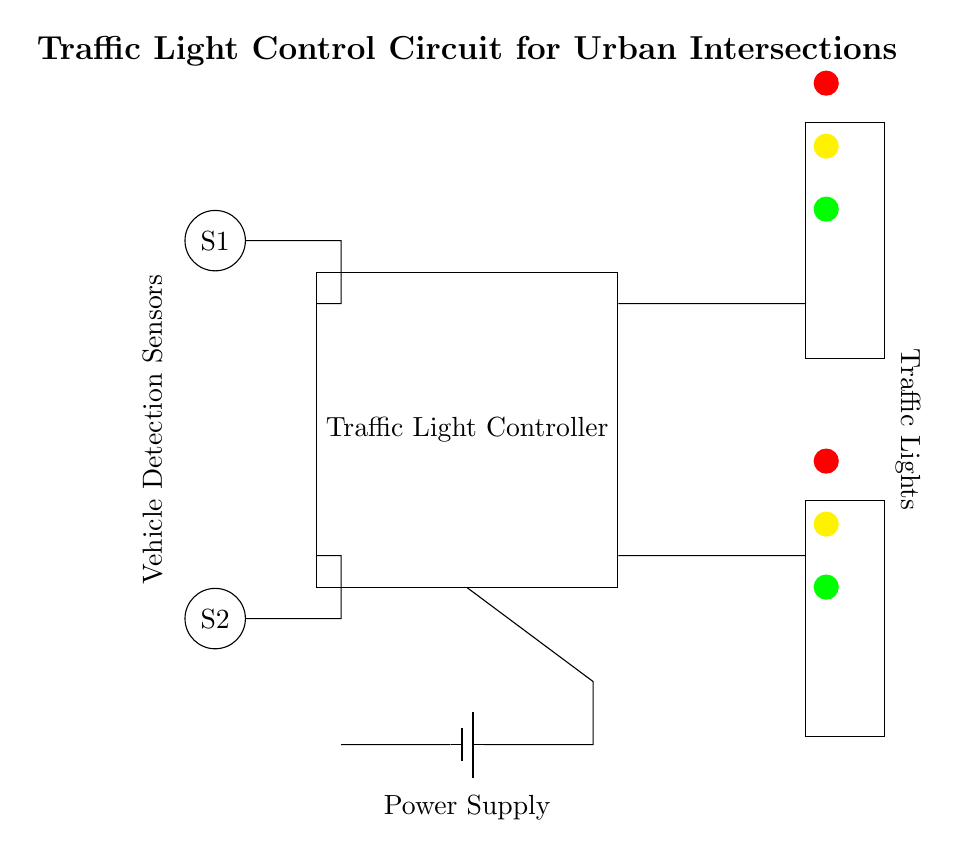What are the main components of this circuit? The main components are the traffic light controller, vehicle detection sensors, traffic lights, and a power supply. Each component serves a specific function: the controller manages the lights, the sensors detect vehicles, the lights signal traffic, and the power supply provides energy to the circuit.
Answer: traffic light controller, vehicle detection sensors, traffic lights, power supply How many vehicle detection sensors are in the circuit? There are two vehicle detection sensors labeled S1 and S2. They are positioned at the top and bottom of the circuit diagram, indicating their function in detecting vehicles at the intersection.
Answer: 2 What is the function of the traffic light controller? The traffic light controller's function is to manage the timing and sequencing of the traffic lights based on the data received from vehicle detection sensors. It determines when to change the lights from red to green and vice versa, ensuring safe traffic flow.
Answer: manage traffic light timing What kind of lights are implemented in this circuit? The circuit implements three colored lights: red, yellow, and green. The red light indicates stop, the yellow light indicates caution, and the green light indicates go, each positioned at appropriate heights in the diagram.
Answer: red, yellow, green What powers the traffic light control circuit? The power supply, represented by a battery symbol in the circuit, powers the entire traffic light control circuit. It is connected to the traffic light controller, delivering the necessary voltage for operation.
Answer: battery How does the traffic light controller receive input from the vehicle detection sensors? The vehicle detection sensors are connected to the traffic light controller, allowing data about vehicle presence to flow into the controller. This input is used to make decisions on traffic light changes, effectively controlling vehicle and pedestrian traffic.
Answer: through connections to the controller 